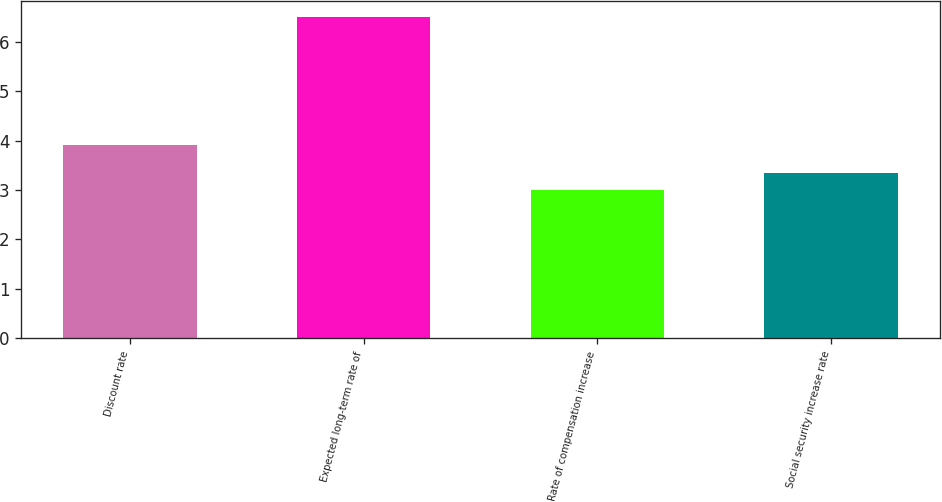<chart> <loc_0><loc_0><loc_500><loc_500><bar_chart><fcel>Discount rate<fcel>Expected long-term rate of<fcel>Rate of compensation increase<fcel>Social security increase rate<nl><fcel>3.9<fcel>6.5<fcel>3<fcel>3.35<nl></chart> 